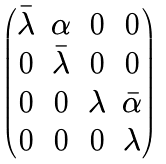Convert formula to latex. <formula><loc_0><loc_0><loc_500><loc_500>\begin{pmatrix} \bar { \lambda } & \alpha & 0 & 0 \\ 0 & \bar { \lambda } & 0 & 0 \\ 0 & 0 & \lambda & \bar { \alpha } \\ 0 & 0 & 0 & \lambda \end{pmatrix}</formula> 